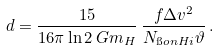<formula> <loc_0><loc_0><loc_500><loc_500>d = \frac { 1 5 } { 1 6 \pi \ln 2 \, G m _ { H } } \, \frac { f \Delta v ^ { 2 } } { N _ { \i o n { H } { i } } \vartheta } \, .</formula> 